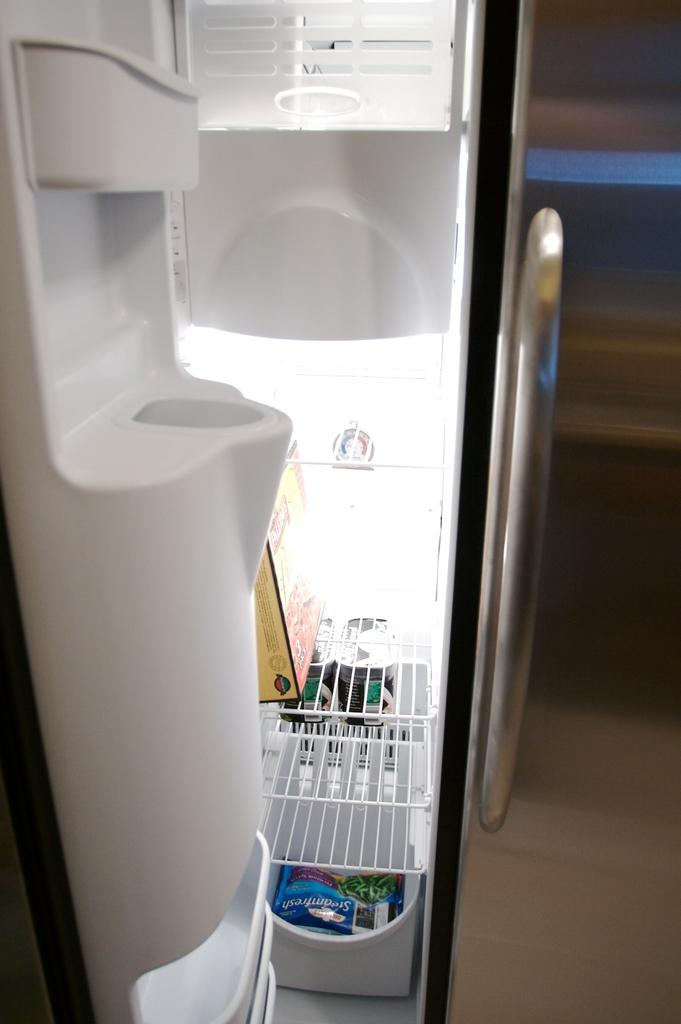<image>
Give a short and clear explanation of the subsequent image. A freezer has a steamfresh vegetable bag in it. 